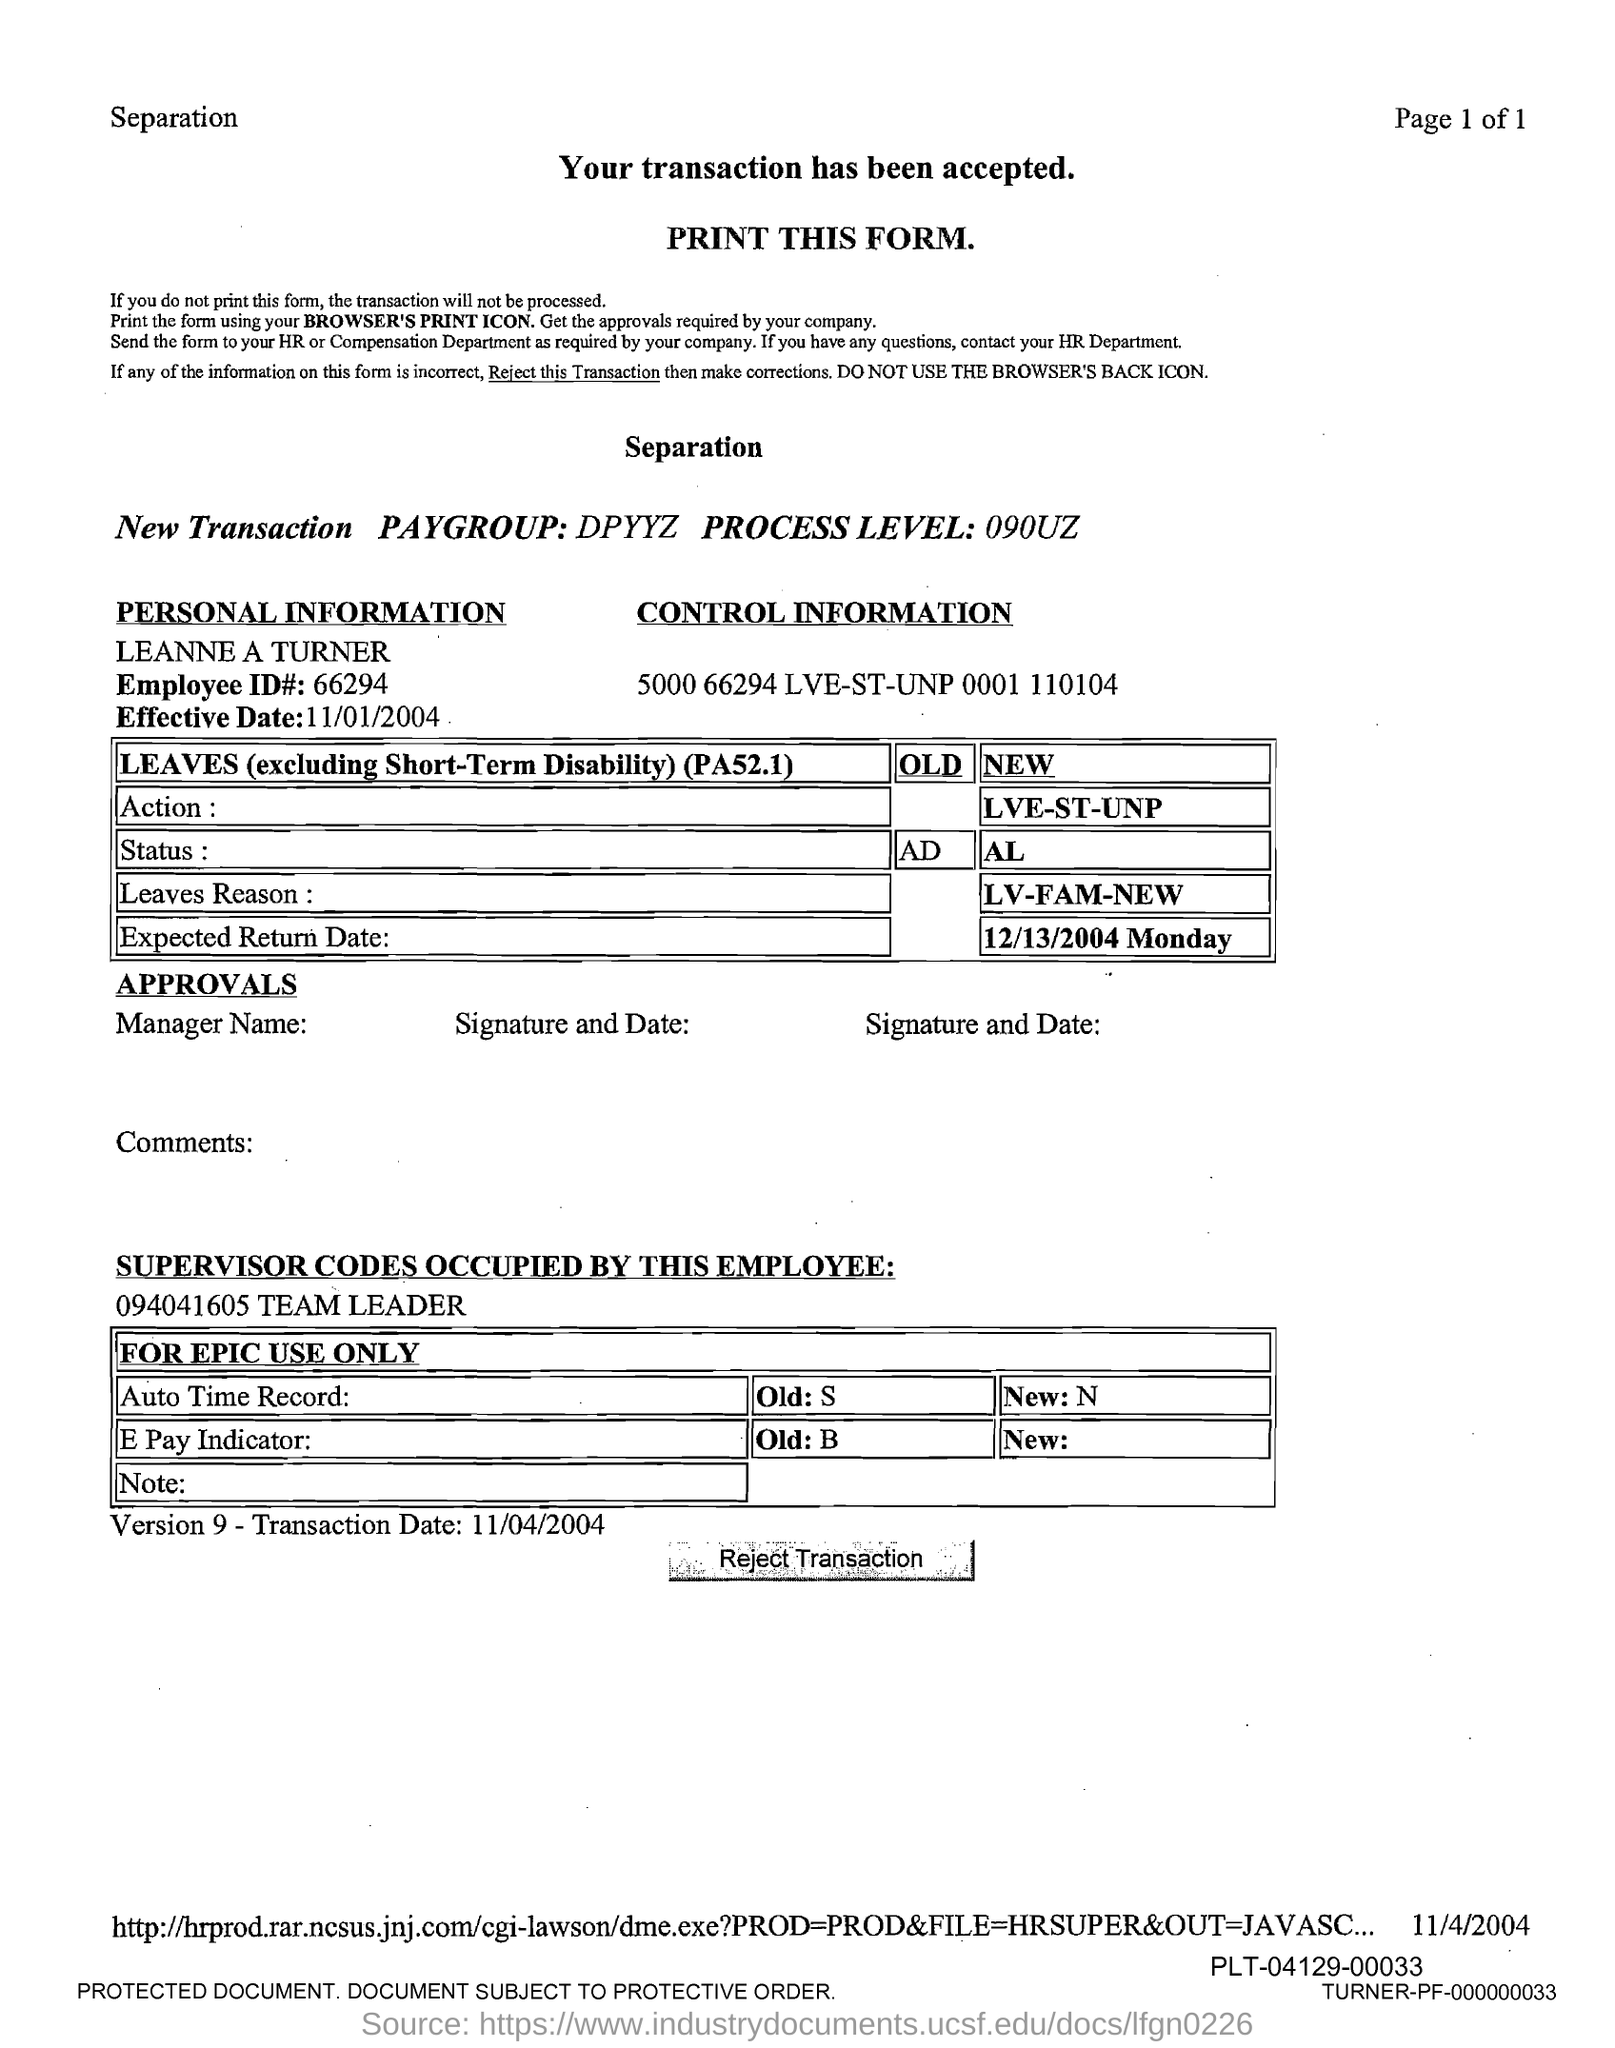What is the employee id#?
Provide a short and direct response. 66294. What is the effective date?
Make the answer very short. 11/01/2004. 